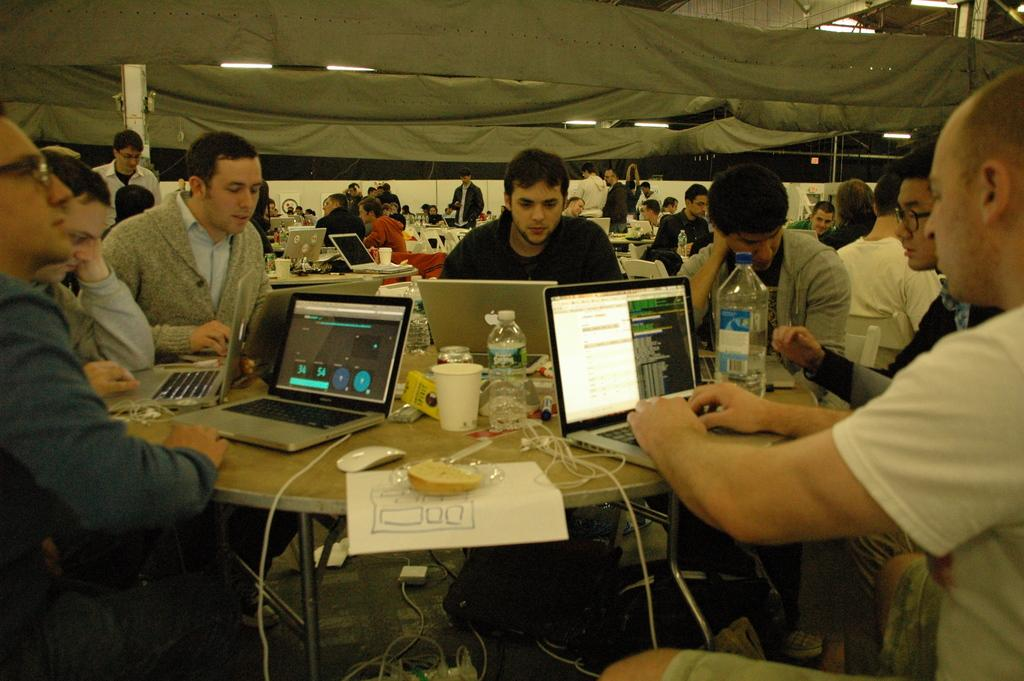What is happening in the image? There are people sitting around a table in the image. What can be seen on the table in the image? There is a bottle on the table in the image, as well as other unspecified items. Can you compare the size of the toy in the image to the size of the river? There is no toy or river present in the image, so it is not possible to make a comparison. 